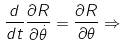Convert formula to latex. <formula><loc_0><loc_0><loc_500><loc_500>\frac { d } { d t } \frac { \partial R } { \partial \dot { \theta } } = \frac { \partial R } { \partial \theta } \Rightarrow</formula> 